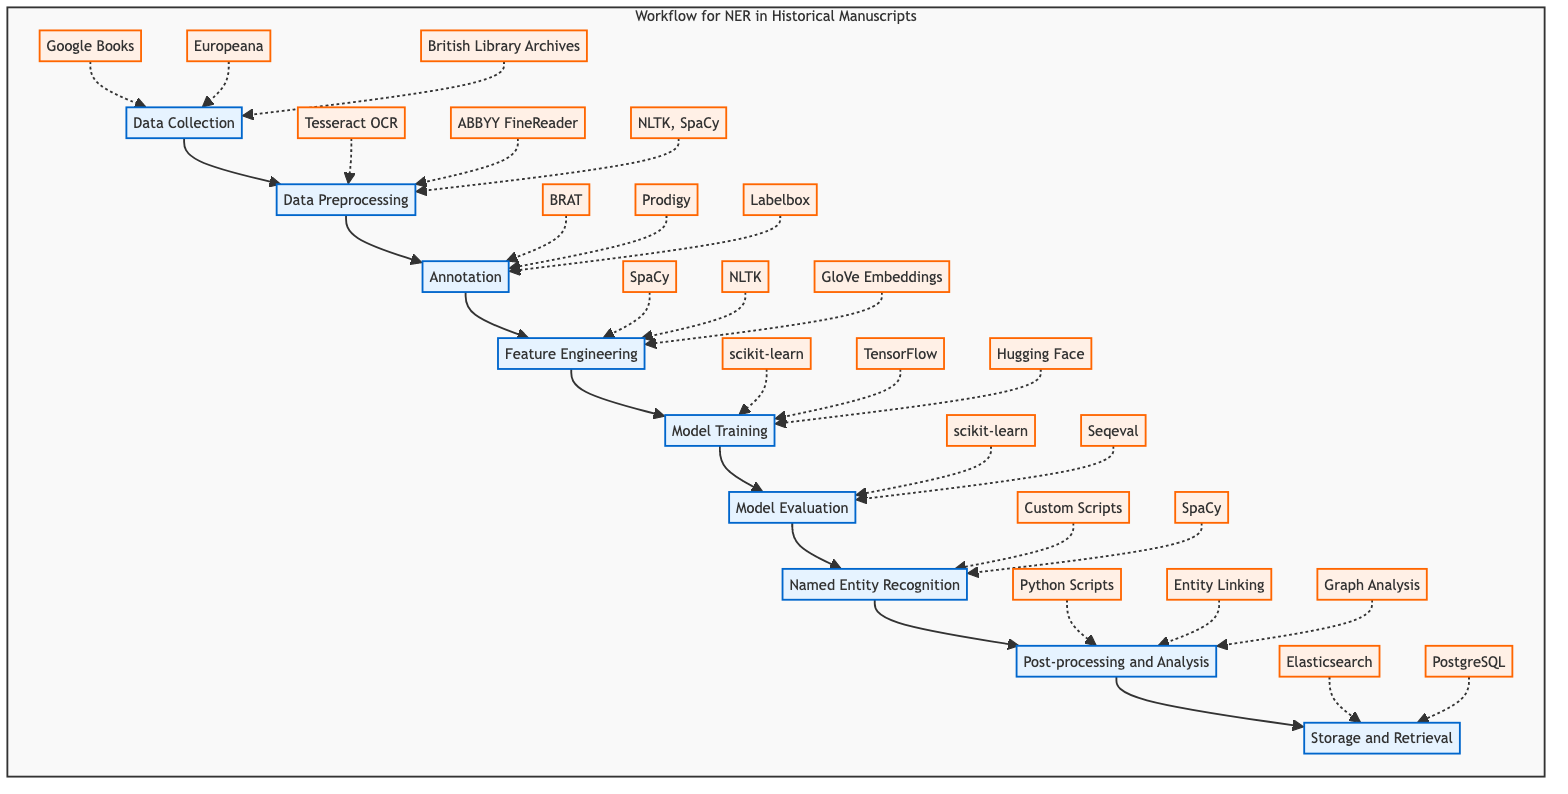What is the first step in the NER workflow? The diagram shows that the first step is "Data Collection." It is the starting point connected to the subsequent steps of the workflow.
Answer: Data Collection How many steps are there in the NER workflow? By counting the nodes in the flowchart, it is clear that there are eight distinct steps depicted in the workflow.
Answer: Eight Which tool is used for model evaluation? The diagram specifies "scikit-learn" and "Seqeval" as tools for the model evaluation step. These are directly connected to the "Model Evaluation" node.
Answer: scikit-learn, Seqeval What comes after model training in the workflow? The flowchart indicates that after "Model Training," the next step is "Model Evaluation," showing a linear progression through the workflow.
Answer: Model Evaluation In which step are named entities applied to the unannotated corpus? The diagram identifies the step for applying the trained NER model to identify named entities as "Named Entity Recognition," which follows after "Model Evaluation."
Answer: Named Entity Recognition How does feature engineering relate to previous steps? The diagram shows that "Feature Engineering" follows "Annotation," indicating that features are extracted from the annotated data generated in the previous step.
Answer: After Annotation What is the last tool listed in the workflow? Looking at the flowchart, the last tool listed under the "Storage and Retrieval" step is "PostgreSQL," which is positioned at the bottom in the workflow.
Answer: PostgreSQL What is the purpose of post-processing in the workflow? The "Post-processing and Analysis" step is designed to refine entity recognition and analyze extracted entities for historical insights, connecting back through the workflow to previous steps.
Answer: Refine entity recognition and analyze extracted entities Which step involves gathering historical manuscript images? The diagram indicates that the "Data Collection" step is responsible for gathering historical manuscript images or text documents, forming the foundation of the entire workflow.
Answer: Data Collection 